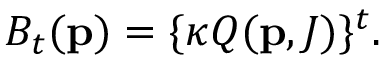Convert formula to latex. <formula><loc_0><loc_0><loc_500><loc_500>B _ { t } ( { p } ) = \{ \kappa Q ( { p } , J ) \} ^ { t } .</formula> 